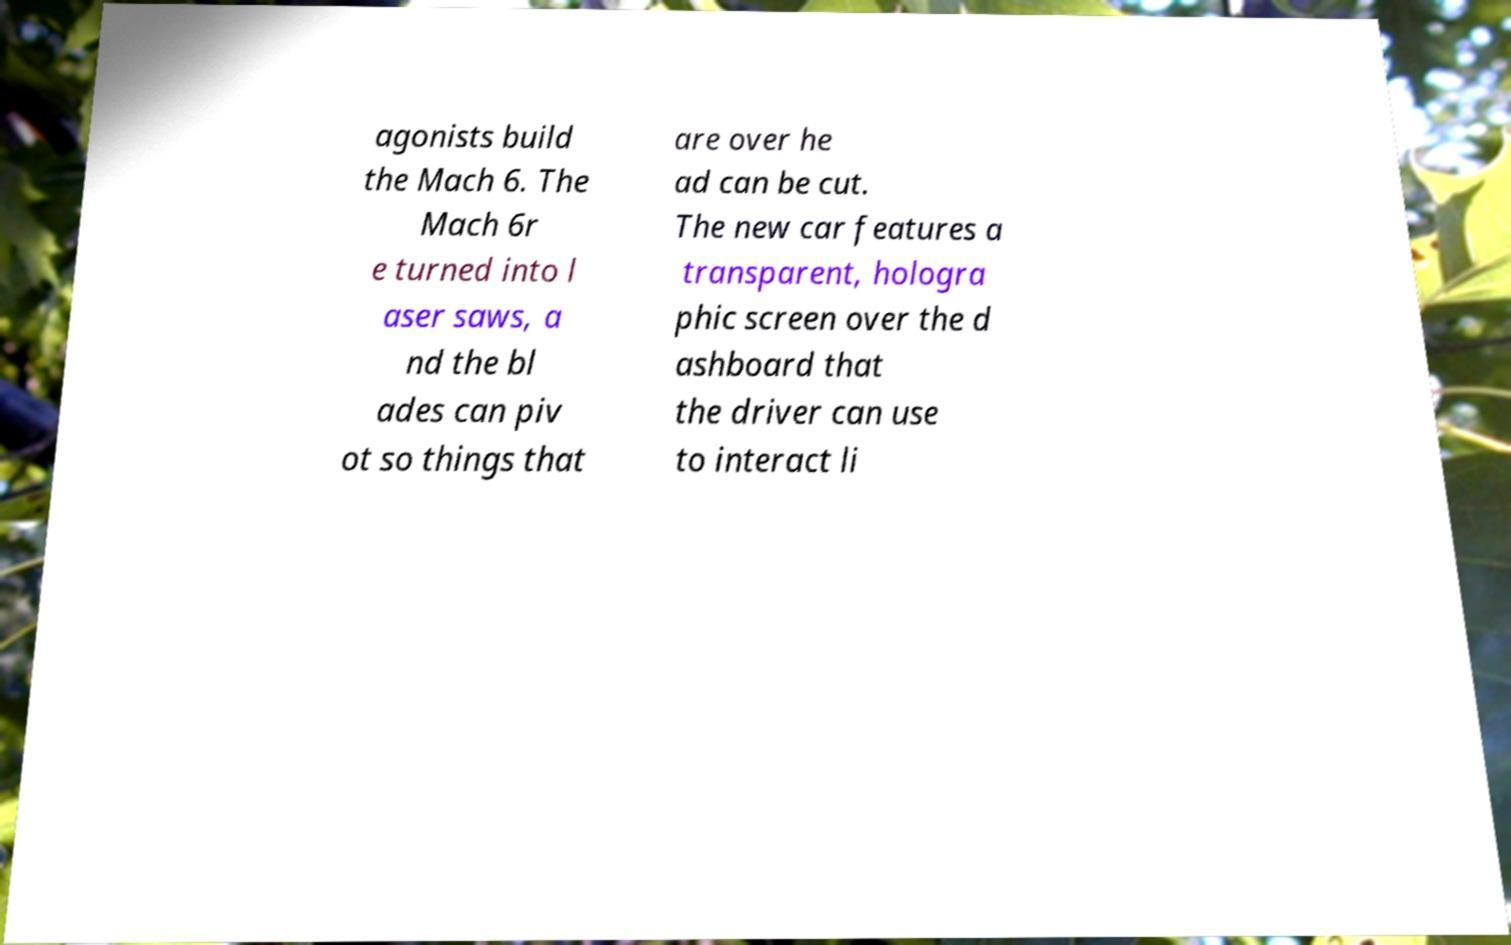Can you accurately transcribe the text from the provided image for me? agonists build the Mach 6. The Mach 6r e turned into l aser saws, a nd the bl ades can piv ot so things that are over he ad can be cut. The new car features a transparent, hologra phic screen over the d ashboard that the driver can use to interact li 